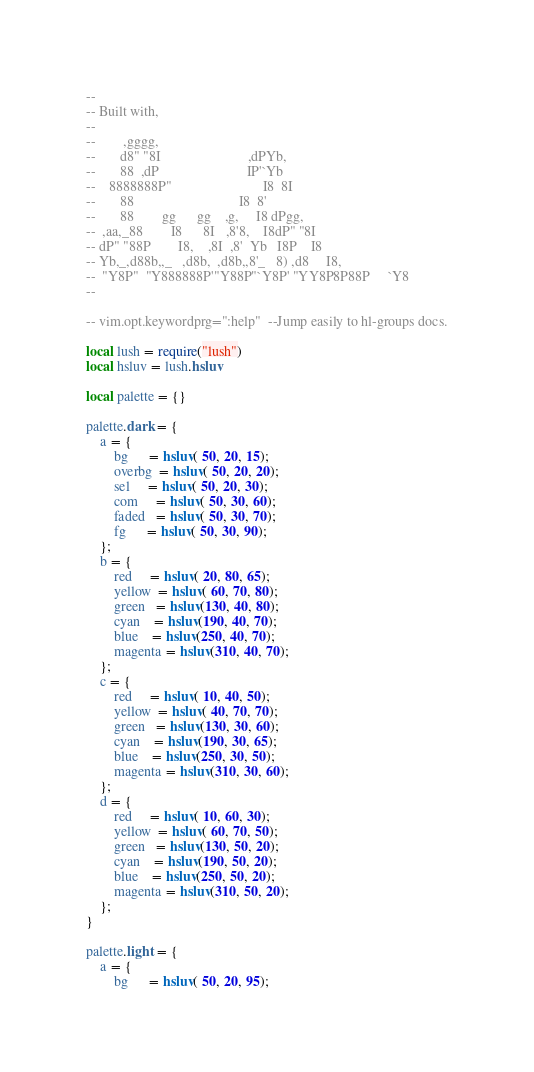Convert code to text. <code><loc_0><loc_0><loc_500><loc_500><_Lua_>--
-- Built with,
--
--        ,gggg,
--       d8" "8I                         ,dPYb,
--       88  ,dP                         IP'`Yb
--    8888888P"                          I8  8I
--       88                              I8  8'
--       88        gg      gg    ,g,     I8 dPgg,
--  ,aa,_88        I8      8I   ,8'8,    I8dP" "8I
-- dP" "88P        I8,    ,8I  ,8'  Yb   I8P    I8
-- Yb,_,d88b,,_   ,d8b,  ,d8b,,8'_   8) ,d8     I8,
--  "Y8P"  "Y888888P'"Y88P"`Y8P' "YY8P8P88P     `Y8
--

-- vim.opt.keywordprg=":help"  --Jump easily to hl-groups docs.

local lush = require("lush")
local hsluv = lush.hsluv

local palette = {}

palette.dark = {
    a = {
        bg      = hsluv( 50, 20, 15);
        overbg  = hsluv( 50, 20, 20);
        sel     = hsluv( 50, 20, 30);
        com     = hsluv( 50, 30, 60);
        faded   = hsluv( 50, 30, 70);
        fg      = hsluv( 50, 30, 90);
    };
    b = {
        red     = hsluv( 20, 80, 65);
        yellow  = hsluv( 60, 70, 80);
        green   = hsluv(130, 40, 80);
        cyan    = hsluv(190, 40, 70);
        blue    = hsluv(250, 40, 70);
        magenta = hsluv(310, 40, 70);
    };
    c = {
        red     = hsluv( 10, 40, 50);
        yellow  = hsluv( 40, 70, 70);
        green   = hsluv(130, 30, 60);
        cyan    = hsluv(190, 30, 65);
        blue    = hsluv(250, 30, 50);
        magenta = hsluv(310, 30, 60);
    };
    d = {
        red     = hsluv( 10, 60, 30);
        yellow  = hsluv( 60, 70, 50);
        green   = hsluv(130, 50, 20);
        cyan    = hsluv(190, 50, 20);
        blue    = hsluv(250, 50, 20);
        magenta = hsluv(310, 50, 20);
    };
}

palette.light = {
    a = {
        bg      = hsluv( 50, 20, 95);</code> 